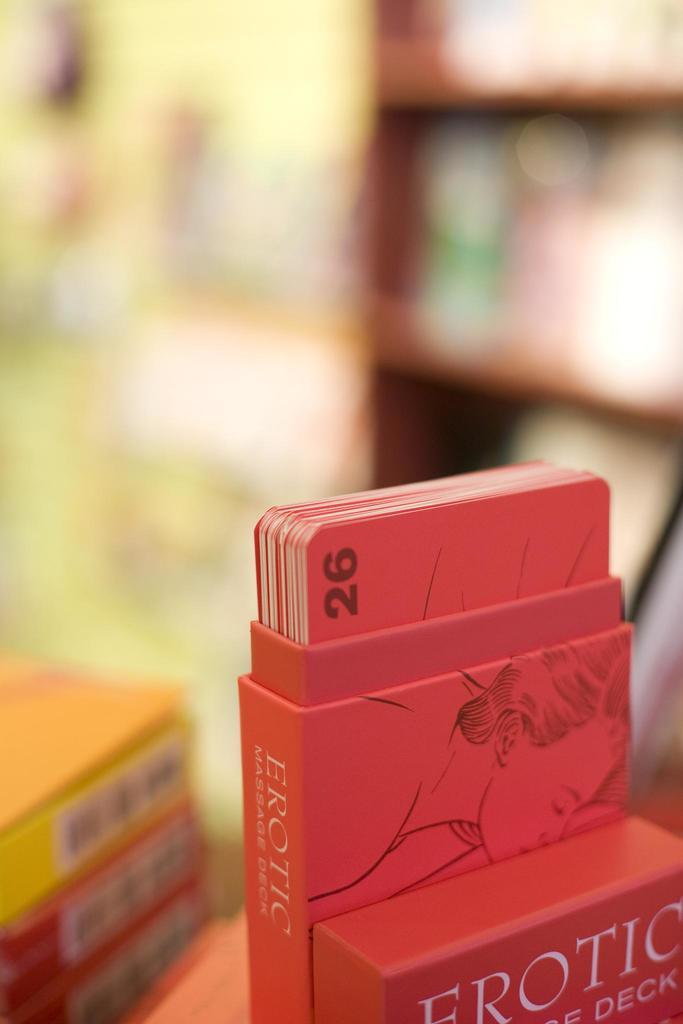<image>
Provide a brief description of the given image. A deck of Erotic cards is displayed in an open box on a table. 